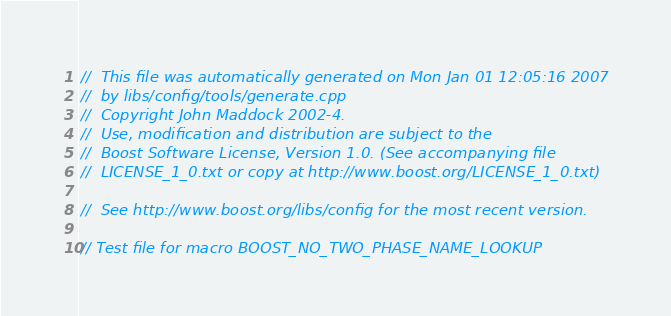<code> <loc_0><loc_0><loc_500><loc_500><_C++_>//  This file was automatically generated on Mon Jan 01 12:05:16 2007
//  by libs/config/tools/generate.cpp
//  Copyright John Maddock 2002-4.
//  Use, modification and distribution are subject to the
//  Boost Software License, Version 1.0. (See accompanying file
//  LICENSE_1_0.txt or copy at http://www.boost.org/LICENSE_1_0.txt)

//  See http://www.boost.org/libs/config for the most recent version.

// Test file for macro BOOST_NO_TWO_PHASE_NAME_LOOKUP</code> 